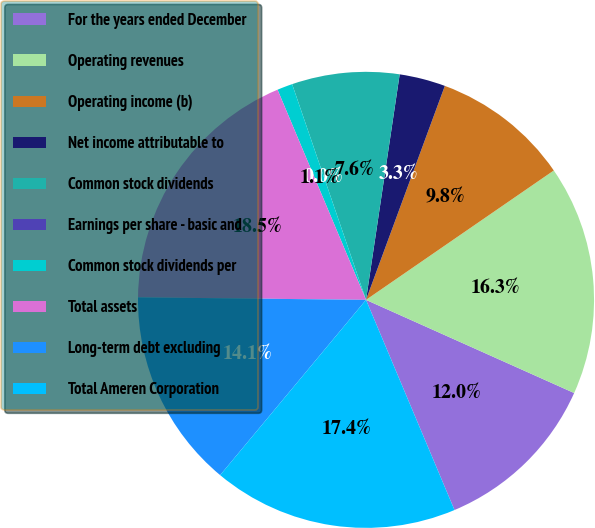Convert chart. <chart><loc_0><loc_0><loc_500><loc_500><pie_chart><fcel>For the years ended December<fcel>Operating revenues<fcel>Operating income (b)<fcel>Net income attributable to<fcel>Common stock dividends<fcel>Earnings per share - basic and<fcel>Common stock dividends per<fcel>Total assets<fcel>Long-term debt excluding<fcel>Total Ameren Corporation<nl><fcel>11.96%<fcel>16.3%<fcel>9.78%<fcel>3.26%<fcel>7.61%<fcel>0.0%<fcel>1.09%<fcel>18.48%<fcel>14.13%<fcel>17.39%<nl></chart> 